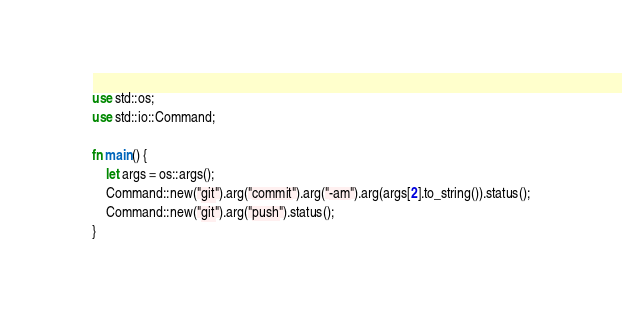<code> <loc_0><loc_0><loc_500><loc_500><_Rust_>use std::os;
use std::io::Command;

fn main() {
    let args = os::args();
    Command::new("git").arg("commit").arg("-am").arg(args[2].to_string()).status();
    Command::new("git").arg("push").status();
}
</code> 